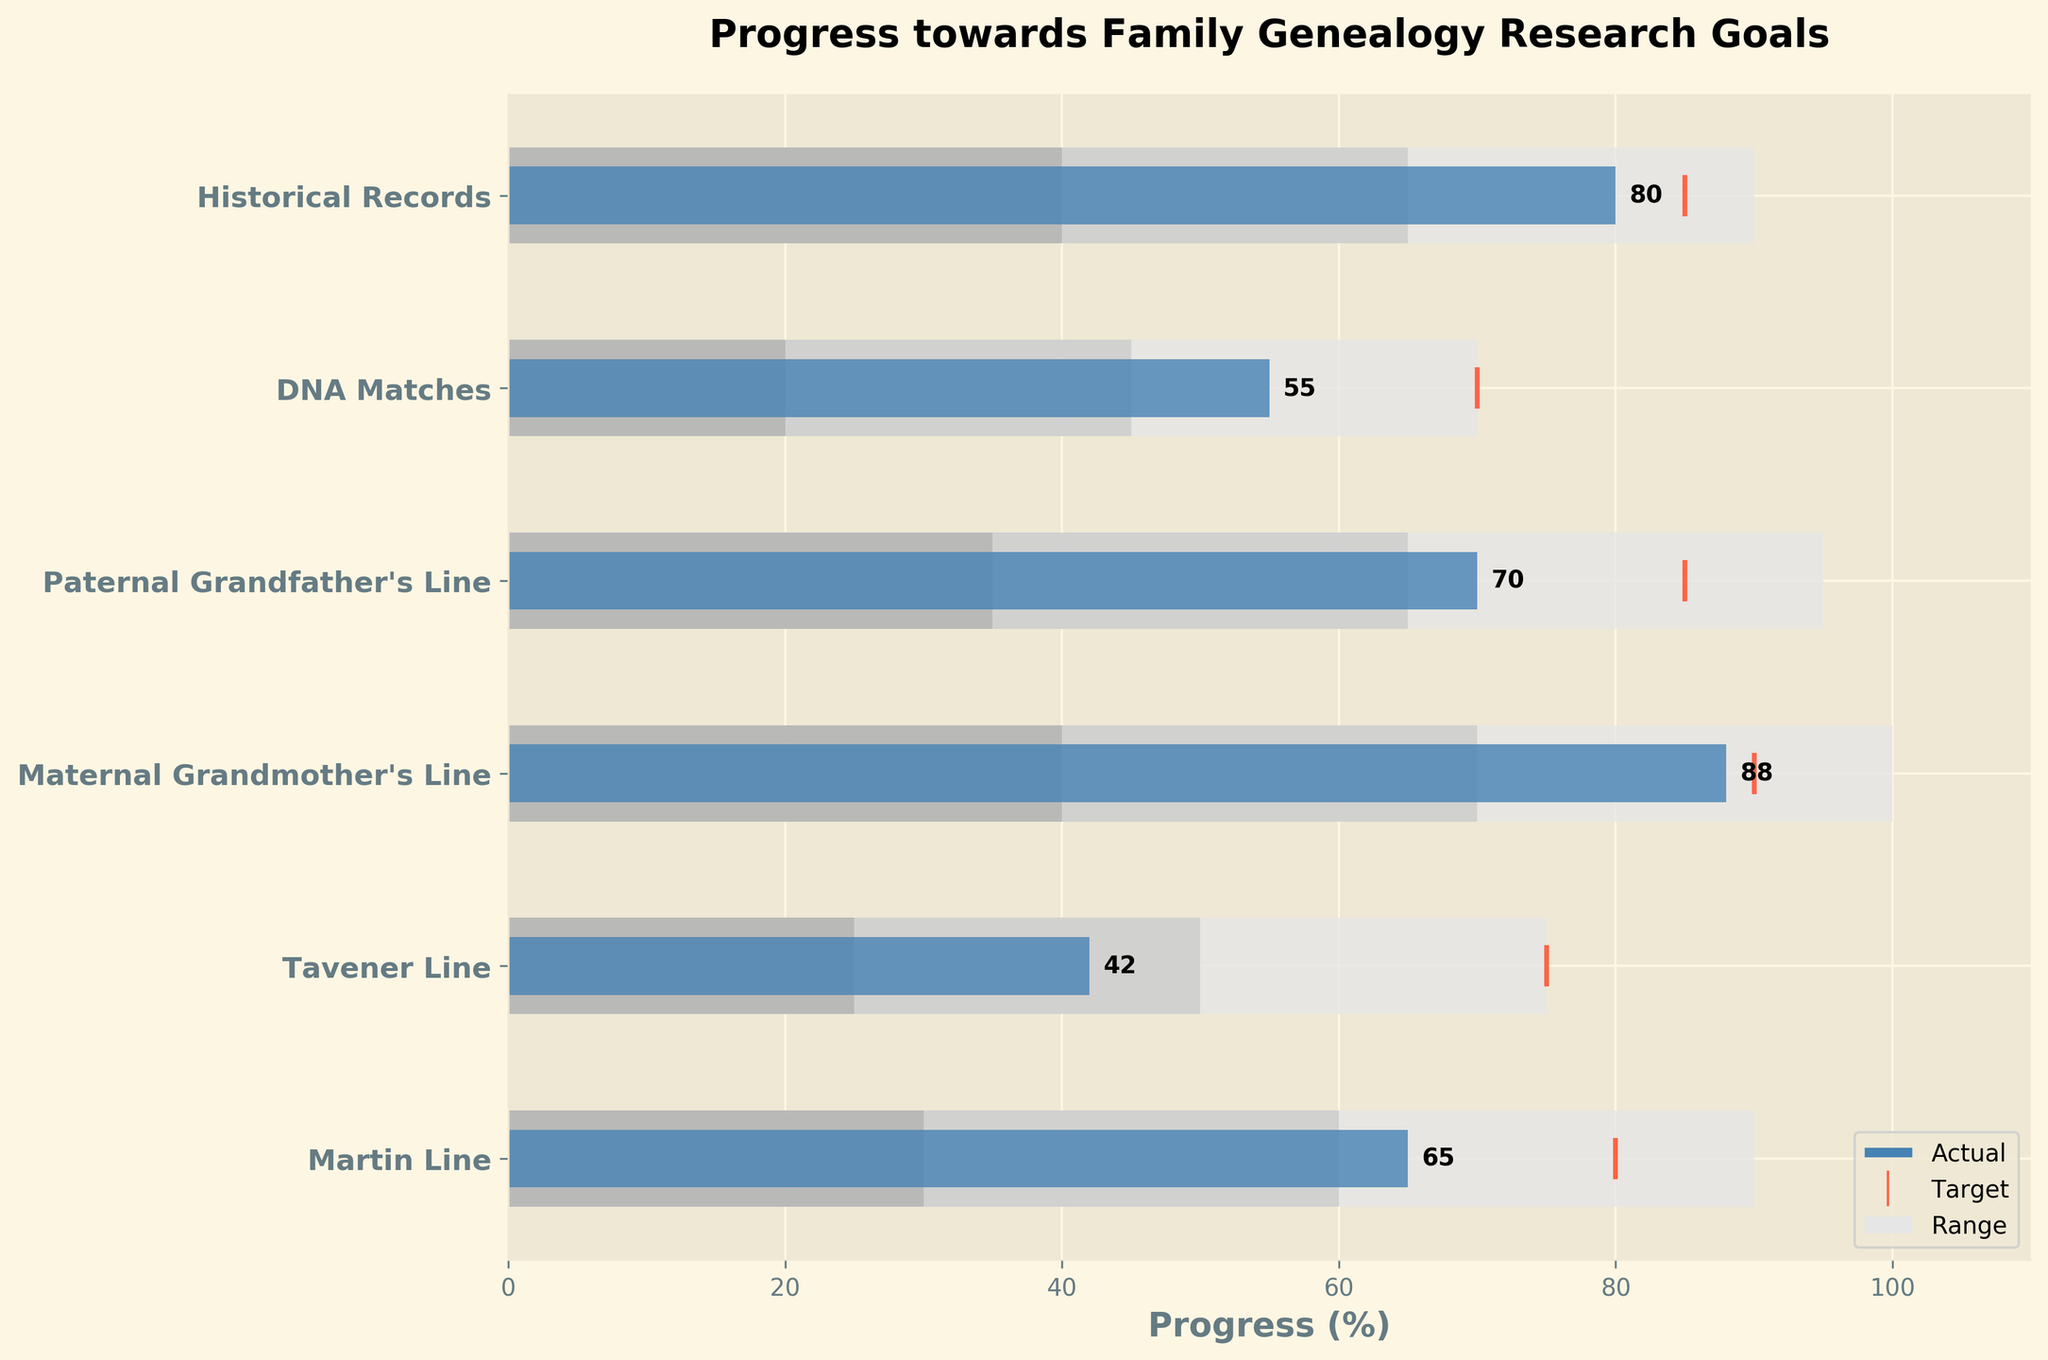How many categories are shown in the bullet chart? There are six rows in the chart, each representing a category. Therefore, there are six categories.
Answer: 6 What is the actual progress for the Martin Line? The actual progress for the Martin Line is represented by the length of the blue bar in the chart, which is 65%.
Answer: 65% Which ancestral line has the highest actual progress? By looking at the blue bars, Maternal Grandmother's Line has the highest actual progress at 88%.
Answer: Maternal Grandmother's Line How does the actual progress of the Tavener Line compare to its target? The actual progress for the Tavener Line is 42%, while the target is 75%. Subtract the actual from the target: 75% - 42% = 33%.
Answer: 33% below target Which category met or exceeded its target? Comparing blue bars with target markers, Maternal Grandmother's Line nearly meets its target, as the actual progress is very close to the target of 90%.
Answer: Maternal Grandmother's Line What is the difference between the actual progress of the DNA Matches and Historical Records? Subtract the actual progress of DNA Matches (55%) from Historical Records (80%): 80% - 55% = 25%.
Answer: 25% Compare the ranges for the Paternal Grandfather's Line and Historical Records. Which has a wider range? For the Paternal Grandfather's Line, Range3 is up to 95%, and for Historical Records, Range3 is up to 90%. The difference is 95% - 90% = 5%; thus, Paternal Grandfather's Line has a wider range.
Answer: Paternal Grandfather's Line What is the range1 value for the Maternal Grandmother's Line? The range1 value is the innermost shaded area for each category; Maternal Grandmother's Line has a range1 value of 40%.
Answer: 40% Which categories have their target marked at 85%? By looking at the orange target markers, the categories with targets of 85% are Paternal Grandfather's Line and Historical Records.
Answer: Paternal Grandfather's Line, Historical Records If the average target for all categories is calculated, what is the result? Add all target values and divide by the number of categories: (80% + 75% + 90% + 85% + 70% + 85%) / 6 = 485% / 6 = 80.83%.
Answer: 80.83% Are there any categories where the actual progress is within the range2 but not range1? By comparing the actual progress bars to the ranges, DNA Matches is the one where actual progress (55%) is within range2 (45-70%) but not within range1 (20-45%).
Answer: DNA Matches 